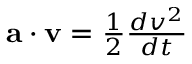Convert formula to latex. <formula><loc_0><loc_0><loc_500><loc_500>a \cdot v = { \frac { 1 } { 2 } } { \frac { d v ^ { 2 } } { d t } }</formula> 